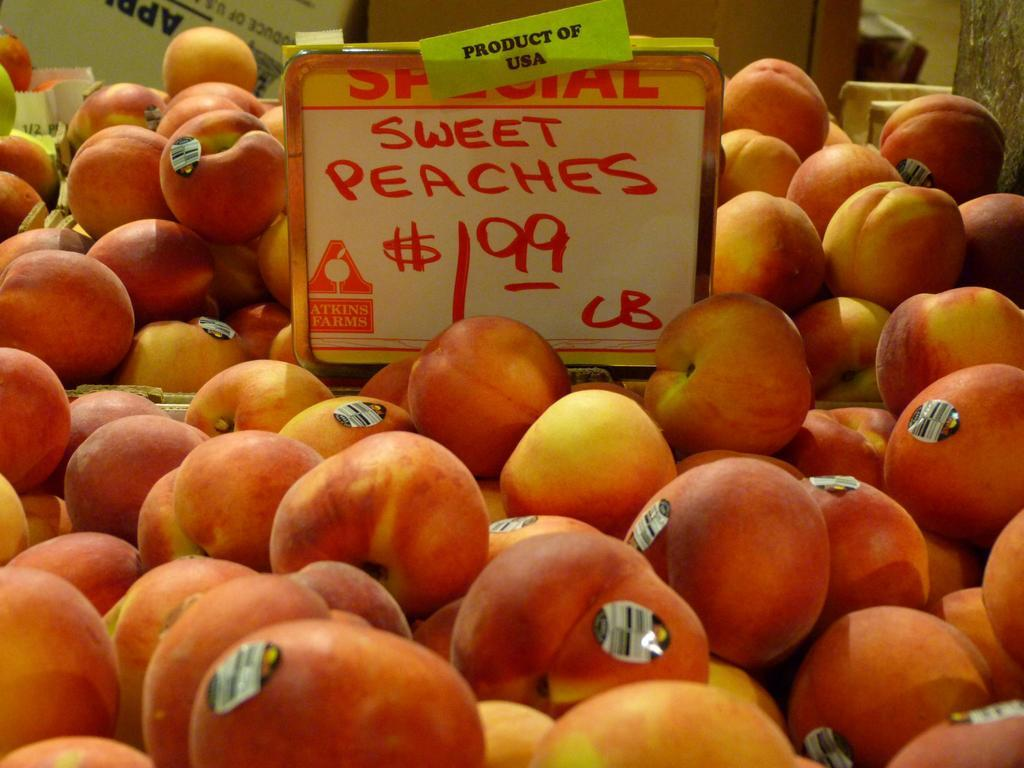What is on the board that is visible in the image? There is a board with text in the image. How are the fruits arranged in the image? The board is placed on a group of fruits. What information is provided about each fruit? Each fruit has a label. What other items can be seen at the top of the image? There are cardboard boxes and bags at the top of the image. What type of cherries are being exchanged in the image? There are no cherries present in the image, and no exchange is taking place. How are the fruits being shown in the image? The fruits are not being shown in the image; they are simply arranged with a board on top of them. 